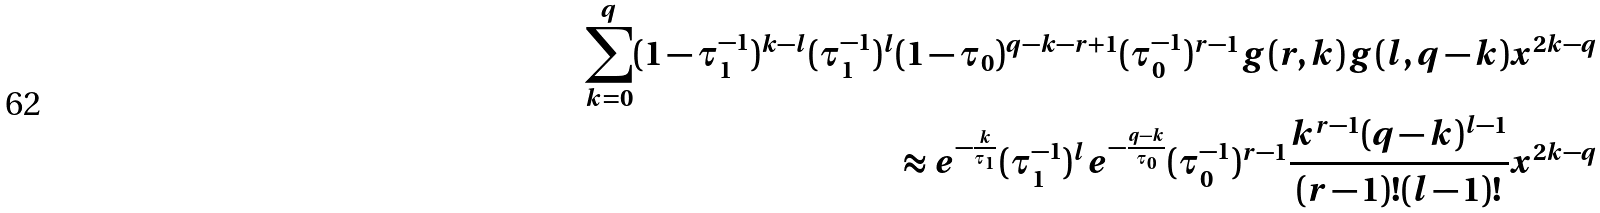<formula> <loc_0><loc_0><loc_500><loc_500>\sum _ { k = 0 } ^ { q } ( 1 - \tau _ { 1 } ^ { - 1 } ) ^ { k - l } ( \tau _ { 1 } ^ { - 1 } ) ^ { l } ( 1 - \tau _ { 0 } ) ^ { q - k - r + 1 } ( \tau _ { 0 } ^ { - 1 } ) ^ { r - 1 } g ( r , k ) g ( l , q - k ) x ^ { 2 k - q } \\ \approx e ^ { - \frac { k } { \tau _ { 1 } } } ( \tau _ { 1 } ^ { - 1 } ) ^ { l } e ^ { - \frac { q - k } { \tau _ { 0 } } } ( \tau _ { 0 } ^ { - 1 } ) ^ { r - 1 } \frac { k ^ { r - 1 } ( q - k ) ^ { l - 1 } } { ( r - 1 ) ! ( l - 1 ) ! } x ^ { 2 k - q }</formula> 